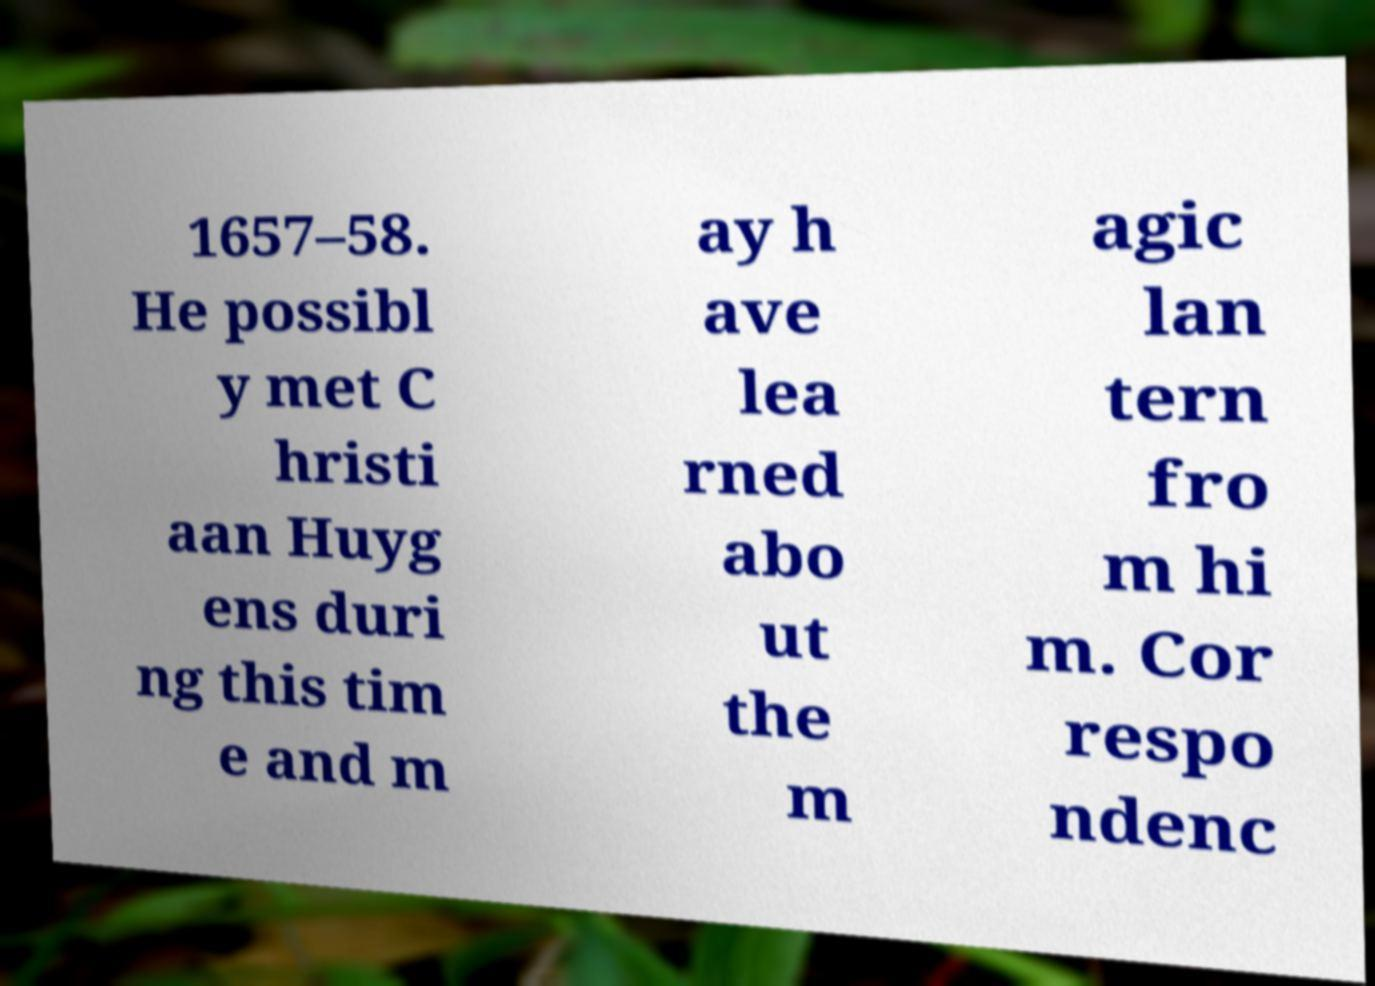Can you read and provide the text displayed in the image?This photo seems to have some interesting text. Can you extract and type it out for me? 1657–58. He possibl y met C hristi aan Huyg ens duri ng this tim e and m ay h ave lea rned abo ut the m agic lan tern fro m hi m. Cor respo ndenc 